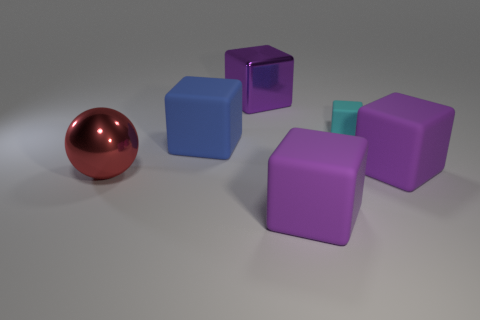How many purple blocks must be subtracted to get 1 purple blocks? 2 Subtract all yellow cylinders. How many purple blocks are left? 3 Subtract all cyan cubes. How many cubes are left? 4 Subtract all blue cubes. How many cubes are left? 4 Add 3 purple cylinders. How many objects exist? 9 Subtract all brown cubes. Subtract all brown spheres. How many cubes are left? 5 Subtract all spheres. How many objects are left? 5 Subtract 3 purple cubes. How many objects are left? 3 Subtract all purple things. Subtract all blue rubber blocks. How many objects are left? 2 Add 3 metal things. How many metal things are left? 5 